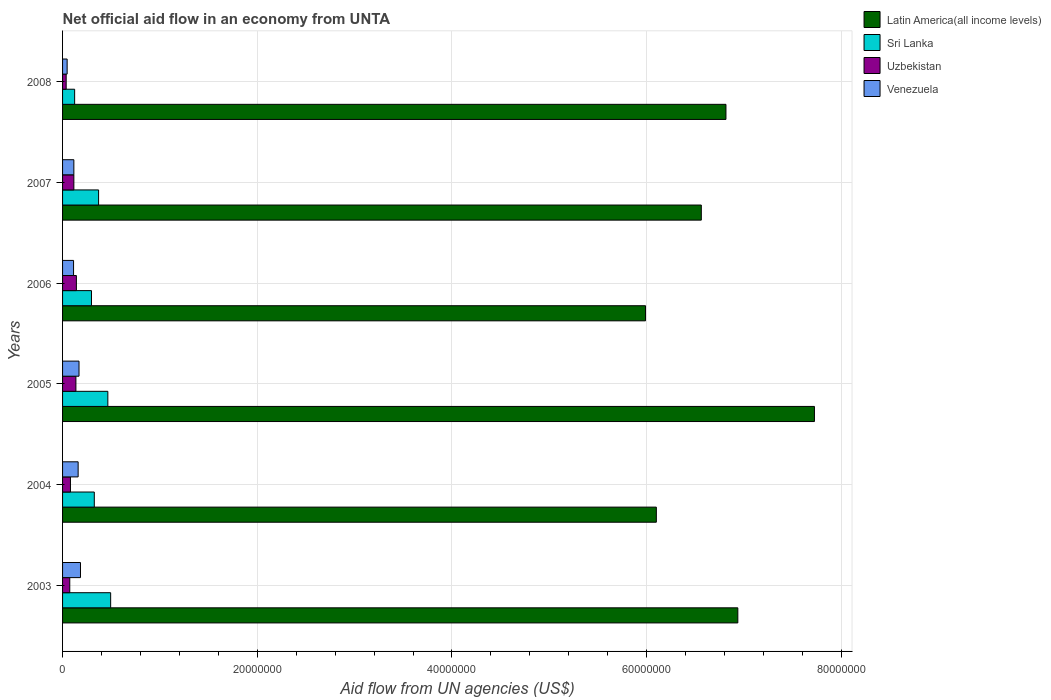Are the number of bars per tick equal to the number of legend labels?
Offer a terse response. Yes. How many bars are there on the 3rd tick from the bottom?
Ensure brevity in your answer.  4. What is the label of the 1st group of bars from the top?
Provide a succinct answer. 2008. In how many cases, is the number of bars for a given year not equal to the number of legend labels?
Give a very brief answer. 0. What is the net official aid flow in Venezuela in 2005?
Offer a very short reply. 1.69e+06. Across all years, what is the maximum net official aid flow in Venezuela?
Provide a short and direct response. 1.84e+06. What is the total net official aid flow in Latin America(all income levels) in the graph?
Your answer should be compact. 4.01e+08. What is the difference between the net official aid flow in Latin America(all income levels) in 2005 and that in 2007?
Offer a terse response. 1.16e+07. What is the average net official aid flow in Latin America(all income levels) per year?
Offer a terse response. 6.69e+07. In the year 2005, what is the difference between the net official aid flow in Latin America(all income levels) and net official aid flow in Sri Lanka?
Make the answer very short. 7.26e+07. In how many years, is the net official aid flow in Uzbekistan greater than 20000000 US$?
Your answer should be very brief. 0. What is the ratio of the net official aid flow in Sri Lanka in 2003 to that in 2008?
Ensure brevity in your answer.  3.98. What is the difference between the highest and the second highest net official aid flow in Sri Lanka?
Ensure brevity in your answer.  2.90e+05. What is the difference between the highest and the lowest net official aid flow in Venezuela?
Ensure brevity in your answer.  1.37e+06. In how many years, is the net official aid flow in Latin America(all income levels) greater than the average net official aid flow in Latin America(all income levels) taken over all years?
Ensure brevity in your answer.  3. Is the sum of the net official aid flow in Sri Lanka in 2003 and 2005 greater than the maximum net official aid flow in Latin America(all income levels) across all years?
Make the answer very short. No. What does the 3rd bar from the top in 2008 represents?
Keep it short and to the point. Sri Lanka. What does the 2nd bar from the bottom in 2008 represents?
Your response must be concise. Sri Lanka. What is the difference between two consecutive major ticks on the X-axis?
Keep it short and to the point. 2.00e+07. Are the values on the major ticks of X-axis written in scientific E-notation?
Make the answer very short. No. Does the graph contain any zero values?
Offer a terse response. No. Does the graph contain grids?
Make the answer very short. Yes. How many legend labels are there?
Provide a short and direct response. 4. How are the legend labels stacked?
Your answer should be compact. Vertical. What is the title of the graph?
Provide a short and direct response. Net official aid flow in an economy from UNTA. Does "Eritrea" appear as one of the legend labels in the graph?
Ensure brevity in your answer.  No. What is the label or title of the X-axis?
Offer a very short reply. Aid flow from UN agencies (US$). What is the label or title of the Y-axis?
Keep it short and to the point. Years. What is the Aid flow from UN agencies (US$) in Latin America(all income levels) in 2003?
Provide a short and direct response. 6.94e+07. What is the Aid flow from UN agencies (US$) in Sri Lanka in 2003?
Offer a terse response. 4.94e+06. What is the Aid flow from UN agencies (US$) in Uzbekistan in 2003?
Your answer should be very brief. 7.40e+05. What is the Aid flow from UN agencies (US$) of Venezuela in 2003?
Provide a succinct answer. 1.84e+06. What is the Aid flow from UN agencies (US$) in Latin America(all income levels) in 2004?
Offer a terse response. 6.10e+07. What is the Aid flow from UN agencies (US$) of Sri Lanka in 2004?
Provide a succinct answer. 3.26e+06. What is the Aid flow from UN agencies (US$) of Uzbekistan in 2004?
Give a very brief answer. 8.10e+05. What is the Aid flow from UN agencies (US$) in Venezuela in 2004?
Your response must be concise. 1.60e+06. What is the Aid flow from UN agencies (US$) in Latin America(all income levels) in 2005?
Your answer should be compact. 7.72e+07. What is the Aid flow from UN agencies (US$) in Sri Lanka in 2005?
Offer a terse response. 4.65e+06. What is the Aid flow from UN agencies (US$) of Uzbekistan in 2005?
Provide a short and direct response. 1.37e+06. What is the Aid flow from UN agencies (US$) in Venezuela in 2005?
Provide a short and direct response. 1.69e+06. What is the Aid flow from UN agencies (US$) in Latin America(all income levels) in 2006?
Offer a very short reply. 5.99e+07. What is the Aid flow from UN agencies (US$) of Sri Lanka in 2006?
Your answer should be very brief. 2.97e+06. What is the Aid flow from UN agencies (US$) in Uzbekistan in 2006?
Offer a terse response. 1.42e+06. What is the Aid flow from UN agencies (US$) in Venezuela in 2006?
Provide a short and direct response. 1.13e+06. What is the Aid flow from UN agencies (US$) in Latin America(all income levels) in 2007?
Give a very brief answer. 6.56e+07. What is the Aid flow from UN agencies (US$) in Sri Lanka in 2007?
Make the answer very short. 3.70e+06. What is the Aid flow from UN agencies (US$) of Uzbekistan in 2007?
Offer a very short reply. 1.16e+06. What is the Aid flow from UN agencies (US$) of Venezuela in 2007?
Keep it short and to the point. 1.16e+06. What is the Aid flow from UN agencies (US$) of Latin America(all income levels) in 2008?
Your answer should be compact. 6.81e+07. What is the Aid flow from UN agencies (US$) of Sri Lanka in 2008?
Give a very brief answer. 1.24e+06. Across all years, what is the maximum Aid flow from UN agencies (US$) of Latin America(all income levels)?
Your response must be concise. 7.72e+07. Across all years, what is the maximum Aid flow from UN agencies (US$) of Sri Lanka?
Keep it short and to the point. 4.94e+06. Across all years, what is the maximum Aid flow from UN agencies (US$) of Uzbekistan?
Provide a short and direct response. 1.42e+06. Across all years, what is the maximum Aid flow from UN agencies (US$) of Venezuela?
Ensure brevity in your answer.  1.84e+06. Across all years, what is the minimum Aid flow from UN agencies (US$) in Latin America(all income levels)?
Offer a terse response. 5.99e+07. Across all years, what is the minimum Aid flow from UN agencies (US$) of Sri Lanka?
Give a very brief answer. 1.24e+06. Across all years, what is the minimum Aid flow from UN agencies (US$) in Uzbekistan?
Your response must be concise. 3.70e+05. What is the total Aid flow from UN agencies (US$) of Latin America(all income levels) in the graph?
Offer a very short reply. 4.01e+08. What is the total Aid flow from UN agencies (US$) in Sri Lanka in the graph?
Offer a terse response. 2.08e+07. What is the total Aid flow from UN agencies (US$) in Uzbekistan in the graph?
Your response must be concise. 5.87e+06. What is the total Aid flow from UN agencies (US$) in Venezuela in the graph?
Your response must be concise. 7.89e+06. What is the difference between the Aid flow from UN agencies (US$) in Latin America(all income levels) in 2003 and that in 2004?
Offer a terse response. 8.37e+06. What is the difference between the Aid flow from UN agencies (US$) of Sri Lanka in 2003 and that in 2004?
Your response must be concise. 1.68e+06. What is the difference between the Aid flow from UN agencies (US$) in Uzbekistan in 2003 and that in 2004?
Keep it short and to the point. -7.00e+04. What is the difference between the Aid flow from UN agencies (US$) of Latin America(all income levels) in 2003 and that in 2005?
Give a very brief answer. -7.87e+06. What is the difference between the Aid flow from UN agencies (US$) of Uzbekistan in 2003 and that in 2005?
Provide a succinct answer. -6.30e+05. What is the difference between the Aid flow from UN agencies (US$) of Venezuela in 2003 and that in 2005?
Your response must be concise. 1.50e+05. What is the difference between the Aid flow from UN agencies (US$) in Latin America(all income levels) in 2003 and that in 2006?
Provide a short and direct response. 9.48e+06. What is the difference between the Aid flow from UN agencies (US$) of Sri Lanka in 2003 and that in 2006?
Offer a terse response. 1.97e+06. What is the difference between the Aid flow from UN agencies (US$) in Uzbekistan in 2003 and that in 2006?
Provide a short and direct response. -6.80e+05. What is the difference between the Aid flow from UN agencies (US$) in Venezuela in 2003 and that in 2006?
Offer a very short reply. 7.10e+05. What is the difference between the Aid flow from UN agencies (US$) in Latin America(all income levels) in 2003 and that in 2007?
Your answer should be very brief. 3.75e+06. What is the difference between the Aid flow from UN agencies (US$) of Sri Lanka in 2003 and that in 2007?
Your answer should be very brief. 1.24e+06. What is the difference between the Aid flow from UN agencies (US$) of Uzbekistan in 2003 and that in 2007?
Your answer should be very brief. -4.20e+05. What is the difference between the Aid flow from UN agencies (US$) in Venezuela in 2003 and that in 2007?
Provide a short and direct response. 6.80e+05. What is the difference between the Aid flow from UN agencies (US$) of Latin America(all income levels) in 2003 and that in 2008?
Keep it short and to the point. 1.22e+06. What is the difference between the Aid flow from UN agencies (US$) in Sri Lanka in 2003 and that in 2008?
Offer a terse response. 3.70e+06. What is the difference between the Aid flow from UN agencies (US$) of Uzbekistan in 2003 and that in 2008?
Give a very brief answer. 3.70e+05. What is the difference between the Aid flow from UN agencies (US$) in Venezuela in 2003 and that in 2008?
Offer a very short reply. 1.37e+06. What is the difference between the Aid flow from UN agencies (US$) of Latin America(all income levels) in 2004 and that in 2005?
Ensure brevity in your answer.  -1.62e+07. What is the difference between the Aid flow from UN agencies (US$) of Sri Lanka in 2004 and that in 2005?
Your answer should be very brief. -1.39e+06. What is the difference between the Aid flow from UN agencies (US$) in Uzbekistan in 2004 and that in 2005?
Give a very brief answer. -5.60e+05. What is the difference between the Aid flow from UN agencies (US$) in Latin America(all income levels) in 2004 and that in 2006?
Provide a succinct answer. 1.11e+06. What is the difference between the Aid flow from UN agencies (US$) of Uzbekistan in 2004 and that in 2006?
Offer a very short reply. -6.10e+05. What is the difference between the Aid flow from UN agencies (US$) of Venezuela in 2004 and that in 2006?
Give a very brief answer. 4.70e+05. What is the difference between the Aid flow from UN agencies (US$) in Latin America(all income levels) in 2004 and that in 2007?
Make the answer very short. -4.62e+06. What is the difference between the Aid flow from UN agencies (US$) of Sri Lanka in 2004 and that in 2007?
Your response must be concise. -4.40e+05. What is the difference between the Aid flow from UN agencies (US$) of Uzbekistan in 2004 and that in 2007?
Give a very brief answer. -3.50e+05. What is the difference between the Aid flow from UN agencies (US$) in Latin America(all income levels) in 2004 and that in 2008?
Ensure brevity in your answer.  -7.15e+06. What is the difference between the Aid flow from UN agencies (US$) in Sri Lanka in 2004 and that in 2008?
Your response must be concise. 2.02e+06. What is the difference between the Aid flow from UN agencies (US$) in Venezuela in 2004 and that in 2008?
Your answer should be very brief. 1.13e+06. What is the difference between the Aid flow from UN agencies (US$) of Latin America(all income levels) in 2005 and that in 2006?
Your response must be concise. 1.74e+07. What is the difference between the Aid flow from UN agencies (US$) in Sri Lanka in 2005 and that in 2006?
Provide a short and direct response. 1.68e+06. What is the difference between the Aid flow from UN agencies (US$) in Uzbekistan in 2005 and that in 2006?
Keep it short and to the point. -5.00e+04. What is the difference between the Aid flow from UN agencies (US$) in Venezuela in 2005 and that in 2006?
Provide a short and direct response. 5.60e+05. What is the difference between the Aid flow from UN agencies (US$) of Latin America(all income levels) in 2005 and that in 2007?
Provide a succinct answer. 1.16e+07. What is the difference between the Aid flow from UN agencies (US$) of Sri Lanka in 2005 and that in 2007?
Make the answer very short. 9.50e+05. What is the difference between the Aid flow from UN agencies (US$) of Venezuela in 2005 and that in 2007?
Offer a terse response. 5.30e+05. What is the difference between the Aid flow from UN agencies (US$) in Latin America(all income levels) in 2005 and that in 2008?
Keep it short and to the point. 9.09e+06. What is the difference between the Aid flow from UN agencies (US$) of Sri Lanka in 2005 and that in 2008?
Your answer should be compact. 3.41e+06. What is the difference between the Aid flow from UN agencies (US$) in Uzbekistan in 2005 and that in 2008?
Give a very brief answer. 1.00e+06. What is the difference between the Aid flow from UN agencies (US$) in Venezuela in 2005 and that in 2008?
Keep it short and to the point. 1.22e+06. What is the difference between the Aid flow from UN agencies (US$) in Latin America(all income levels) in 2006 and that in 2007?
Keep it short and to the point. -5.73e+06. What is the difference between the Aid flow from UN agencies (US$) of Sri Lanka in 2006 and that in 2007?
Offer a terse response. -7.30e+05. What is the difference between the Aid flow from UN agencies (US$) of Latin America(all income levels) in 2006 and that in 2008?
Offer a terse response. -8.26e+06. What is the difference between the Aid flow from UN agencies (US$) in Sri Lanka in 2006 and that in 2008?
Ensure brevity in your answer.  1.73e+06. What is the difference between the Aid flow from UN agencies (US$) in Uzbekistan in 2006 and that in 2008?
Offer a very short reply. 1.05e+06. What is the difference between the Aid flow from UN agencies (US$) of Latin America(all income levels) in 2007 and that in 2008?
Your answer should be very brief. -2.53e+06. What is the difference between the Aid flow from UN agencies (US$) of Sri Lanka in 2007 and that in 2008?
Make the answer very short. 2.46e+06. What is the difference between the Aid flow from UN agencies (US$) in Uzbekistan in 2007 and that in 2008?
Your answer should be compact. 7.90e+05. What is the difference between the Aid flow from UN agencies (US$) of Venezuela in 2007 and that in 2008?
Keep it short and to the point. 6.90e+05. What is the difference between the Aid flow from UN agencies (US$) of Latin America(all income levels) in 2003 and the Aid flow from UN agencies (US$) of Sri Lanka in 2004?
Your response must be concise. 6.61e+07. What is the difference between the Aid flow from UN agencies (US$) in Latin America(all income levels) in 2003 and the Aid flow from UN agencies (US$) in Uzbekistan in 2004?
Give a very brief answer. 6.86e+07. What is the difference between the Aid flow from UN agencies (US$) of Latin America(all income levels) in 2003 and the Aid flow from UN agencies (US$) of Venezuela in 2004?
Provide a succinct answer. 6.78e+07. What is the difference between the Aid flow from UN agencies (US$) of Sri Lanka in 2003 and the Aid flow from UN agencies (US$) of Uzbekistan in 2004?
Provide a succinct answer. 4.13e+06. What is the difference between the Aid flow from UN agencies (US$) of Sri Lanka in 2003 and the Aid flow from UN agencies (US$) of Venezuela in 2004?
Keep it short and to the point. 3.34e+06. What is the difference between the Aid flow from UN agencies (US$) in Uzbekistan in 2003 and the Aid flow from UN agencies (US$) in Venezuela in 2004?
Your answer should be compact. -8.60e+05. What is the difference between the Aid flow from UN agencies (US$) of Latin America(all income levels) in 2003 and the Aid flow from UN agencies (US$) of Sri Lanka in 2005?
Your answer should be very brief. 6.47e+07. What is the difference between the Aid flow from UN agencies (US$) in Latin America(all income levels) in 2003 and the Aid flow from UN agencies (US$) in Uzbekistan in 2005?
Provide a short and direct response. 6.80e+07. What is the difference between the Aid flow from UN agencies (US$) of Latin America(all income levels) in 2003 and the Aid flow from UN agencies (US$) of Venezuela in 2005?
Offer a very short reply. 6.77e+07. What is the difference between the Aid flow from UN agencies (US$) of Sri Lanka in 2003 and the Aid flow from UN agencies (US$) of Uzbekistan in 2005?
Provide a succinct answer. 3.57e+06. What is the difference between the Aid flow from UN agencies (US$) in Sri Lanka in 2003 and the Aid flow from UN agencies (US$) in Venezuela in 2005?
Provide a succinct answer. 3.25e+06. What is the difference between the Aid flow from UN agencies (US$) in Uzbekistan in 2003 and the Aid flow from UN agencies (US$) in Venezuela in 2005?
Your response must be concise. -9.50e+05. What is the difference between the Aid flow from UN agencies (US$) of Latin America(all income levels) in 2003 and the Aid flow from UN agencies (US$) of Sri Lanka in 2006?
Provide a succinct answer. 6.64e+07. What is the difference between the Aid flow from UN agencies (US$) in Latin America(all income levels) in 2003 and the Aid flow from UN agencies (US$) in Uzbekistan in 2006?
Offer a very short reply. 6.79e+07. What is the difference between the Aid flow from UN agencies (US$) in Latin America(all income levels) in 2003 and the Aid flow from UN agencies (US$) in Venezuela in 2006?
Your response must be concise. 6.82e+07. What is the difference between the Aid flow from UN agencies (US$) of Sri Lanka in 2003 and the Aid flow from UN agencies (US$) of Uzbekistan in 2006?
Offer a terse response. 3.52e+06. What is the difference between the Aid flow from UN agencies (US$) in Sri Lanka in 2003 and the Aid flow from UN agencies (US$) in Venezuela in 2006?
Keep it short and to the point. 3.81e+06. What is the difference between the Aid flow from UN agencies (US$) in Uzbekistan in 2003 and the Aid flow from UN agencies (US$) in Venezuela in 2006?
Your answer should be compact. -3.90e+05. What is the difference between the Aid flow from UN agencies (US$) of Latin America(all income levels) in 2003 and the Aid flow from UN agencies (US$) of Sri Lanka in 2007?
Keep it short and to the point. 6.57e+07. What is the difference between the Aid flow from UN agencies (US$) in Latin America(all income levels) in 2003 and the Aid flow from UN agencies (US$) in Uzbekistan in 2007?
Provide a succinct answer. 6.82e+07. What is the difference between the Aid flow from UN agencies (US$) in Latin America(all income levels) in 2003 and the Aid flow from UN agencies (US$) in Venezuela in 2007?
Give a very brief answer. 6.82e+07. What is the difference between the Aid flow from UN agencies (US$) of Sri Lanka in 2003 and the Aid flow from UN agencies (US$) of Uzbekistan in 2007?
Provide a short and direct response. 3.78e+06. What is the difference between the Aid flow from UN agencies (US$) of Sri Lanka in 2003 and the Aid flow from UN agencies (US$) of Venezuela in 2007?
Make the answer very short. 3.78e+06. What is the difference between the Aid flow from UN agencies (US$) in Uzbekistan in 2003 and the Aid flow from UN agencies (US$) in Venezuela in 2007?
Provide a succinct answer. -4.20e+05. What is the difference between the Aid flow from UN agencies (US$) in Latin America(all income levels) in 2003 and the Aid flow from UN agencies (US$) in Sri Lanka in 2008?
Keep it short and to the point. 6.81e+07. What is the difference between the Aid flow from UN agencies (US$) of Latin America(all income levels) in 2003 and the Aid flow from UN agencies (US$) of Uzbekistan in 2008?
Your response must be concise. 6.90e+07. What is the difference between the Aid flow from UN agencies (US$) in Latin America(all income levels) in 2003 and the Aid flow from UN agencies (US$) in Venezuela in 2008?
Offer a very short reply. 6.89e+07. What is the difference between the Aid flow from UN agencies (US$) of Sri Lanka in 2003 and the Aid flow from UN agencies (US$) of Uzbekistan in 2008?
Provide a succinct answer. 4.57e+06. What is the difference between the Aid flow from UN agencies (US$) of Sri Lanka in 2003 and the Aid flow from UN agencies (US$) of Venezuela in 2008?
Offer a terse response. 4.47e+06. What is the difference between the Aid flow from UN agencies (US$) in Uzbekistan in 2003 and the Aid flow from UN agencies (US$) in Venezuela in 2008?
Offer a terse response. 2.70e+05. What is the difference between the Aid flow from UN agencies (US$) of Latin America(all income levels) in 2004 and the Aid flow from UN agencies (US$) of Sri Lanka in 2005?
Offer a very short reply. 5.63e+07. What is the difference between the Aid flow from UN agencies (US$) in Latin America(all income levels) in 2004 and the Aid flow from UN agencies (US$) in Uzbekistan in 2005?
Offer a very short reply. 5.96e+07. What is the difference between the Aid flow from UN agencies (US$) of Latin America(all income levels) in 2004 and the Aid flow from UN agencies (US$) of Venezuela in 2005?
Provide a succinct answer. 5.93e+07. What is the difference between the Aid flow from UN agencies (US$) of Sri Lanka in 2004 and the Aid flow from UN agencies (US$) of Uzbekistan in 2005?
Your answer should be compact. 1.89e+06. What is the difference between the Aid flow from UN agencies (US$) of Sri Lanka in 2004 and the Aid flow from UN agencies (US$) of Venezuela in 2005?
Offer a very short reply. 1.57e+06. What is the difference between the Aid flow from UN agencies (US$) in Uzbekistan in 2004 and the Aid flow from UN agencies (US$) in Venezuela in 2005?
Keep it short and to the point. -8.80e+05. What is the difference between the Aid flow from UN agencies (US$) of Latin America(all income levels) in 2004 and the Aid flow from UN agencies (US$) of Sri Lanka in 2006?
Provide a short and direct response. 5.80e+07. What is the difference between the Aid flow from UN agencies (US$) in Latin America(all income levels) in 2004 and the Aid flow from UN agencies (US$) in Uzbekistan in 2006?
Your response must be concise. 5.96e+07. What is the difference between the Aid flow from UN agencies (US$) of Latin America(all income levels) in 2004 and the Aid flow from UN agencies (US$) of Venezuela in 2006?
Ensure brevity in your answer.  5.99e+07. What is the difference between the Aid flow from UN agencies (US$) of Sri Lanka in 2004 and the Aid flow from UN agencies (US$) of Uzbekistan in 2006?
Your response must be concise. 1.84e+06. What is the difference between the Aid flow from UN agencies (US$) in Sri Lanka in 2004 and the Aid flow from UN agencies (US$) in Venezuela in 2006?
Your answer should be compact. 2.13e+06. What is the difference between the Aid flow from UN agencies (US$) in Uzbekistan in 2004 and the Aid flow from UN agencies (US$) in Venezuela in 2006?
Ensure brevity in your answer.  -3.20e+05. What is the difference between the Aid flow from UN agencies (US$) in Latin America(all income levels) in 2004 and the Aid flow from UN agencies (US$) in Sri Lanka in 2007?
Your answer should be compact. 5.73e+07. What is the difference between the Aid flow from UN agencies (US$) of Latin America(all income levels) in 2004 and the Aid flow from UN agencies (US$) of Uzbekistan in 2007?
Offer a terse response. 5.98e+07. What is the difference between the Aid flow from UN agencies (US$) of Latin America(all income levels) in 2004 and the Aid flow from UN agencies (US$) of Venezuela in 2007?
Your response must be concise. 5.98e+07. What is the difference between the Aid flow from UN agencies (US$) in Sri Lanka in 2004 and the Aid flow from UN agencies (US$) in Uzbekistan in 2007?
Keep it short and to the point. 2.10e+06. What is the difference between the Aid flow from UN agencies (US$) of Sri Lanka in 2004 and the Aid flow from UN agencies (US$) of Venezuela in 2007?
Offer a terse response. 2.10e+06. What is the difference between the Aid flow from UN agencies (US$) of Uzbekistan in 2004 and the Aid flow from UN agencies (US$) of Venezuela in 2007?
Give a very brief answer. -3.50e+05. What is the difference between the Aid flow from UN agencies (US$) of Latin America(all income levels) in 2004 and the Aid flow from UN agencies (US$) of Sri Lanka in 2008?
Your response must be concise. 5.98e+07. What is the difference between the Aid flow from UN agencies (US$) of Latin America(all income levels) in 2004 and the Aid flow from UN agencies (US$) of Uzbekistan in 2008?
Offer a very short reply. 6.06e+07. What is the difference between the Aid flow from UN agencies (US$) in Latin America(all income levels) in 2004 and the Aid flow from UN agencies (US$) in Venezuela in 2008?
Give a very brief answer. 6.05e+07. What is the difference between the Aid flow from UN agencies (US$) of Sri Lanka in 2004 and the Aid flow from UN agencies (US$) of Uzbekistan in 2008?
Provide a succinct answer. 2.89e+06. What is the difference between the Aid flow from UN agencies (US$) in Sri Lanka in 2004 and the Aid flow from UN agencies (US$) in Venezuela in 2008?
Provide a short and direct response. 2.79e+06. What is the difference between the Aid flow from UN agencies (US$) of Uzbekistan in 2004 and the Aid flow from UN agencies (US$) of Venezuela in 2008?
Ensure brevity in your answer.  3.40e+05. What is the difference between the Aid flow from UN agencies (US$) of Latin America(all income levels) in 2005 and the Aid flow from UN agencies (US$) of Sri Lanka in 2006?
Offer a terse response. 7.43e+07. What is the difference between the Aid flow from UN agencies (US$) in Latin America(all income levels) in 2005 and the Aid flow from UN agencies (US$) in Uzbekistan in 2006?
Give a very brief answer. 7.58e+07. What is the difference between the Aid flow from UN agencies (US$) of Latin America(all income levels) in 2005 and the Aid flow from UN agencies (US$) of Venezuela in 2006?
Your response must be concise. 7.61e+07. What is the difference between the Aid flow from UN agencies (US$) in Sri Lanka in 2005 and the Aid flow from UN agencies (US$) in Uzbekistan in 2006?
Provide a succinct answer. 3.23e+06. What is the difference between the Aid flow from UN agencies (US$) of Sri Lanka in 2005 and the Aid flow from UN agencies (US$) of Venezuela in 2006?
Ensure brevity in your answer.  3.52e+06. What is the difference between the Aid flow from UN agencies (US$) in Latin America(all income levels) in 2005 and the Aid flow from UN agencies (US$) in Sri Lanka in 2007?
Offer a terse response. 7.35e+07. What is the difference between the Aid flow from UN agencies (US$) of Latin America(all income levels) in 2005 and the Aid flow from UN agencies (US$) of Uzbekistan in 2007?
Provide a short and direct response. 7.61e+07. What is the difference between the Aid flow from UN agencies (US$) in Latin America(all income levels) in 2005 and the Aid flow from UN agencies (US$) in Venezuela in 2007?
Your response must be concise. 7.61e+07. What is the difference between the Aid flow from UN agencies (US$) of Sri Lanka in 2005 and the Aid flow from UN agencies (US$) of Uzbekistan in 2007?
Your answer should be very brief. 3.49e+06. What is the difference between the Aid flow from UN agencies (US$) in Sri Lanka in 2005 and the Aid flow from UN agencies (US$) in Venezuela in 2007?
Your answer should be compact. 3.49e+06. What is the difference between the Aid flow from UN agencies (US$) in Latin America(all income levels) in 2005 and the Aid flow from UN agencies (US$) in Sri Lanka in 2008?
Provide a succinct answer. 7.60e+07. What is the difference between the Aid flow from UN agencies (US$) in Latin America(all income levels) in 2005 and the Aid flow from UN agencies (US$) in Uzbekistan in 2008?
Offer a terse response. 7.69e+07. What is the difference between the Aid flow from UN agencies (US$) in Latin America(all income levels) in 2005 and the Aid flow from UN agencies (US$) in Venezuela in 2008?
Give a very brief answer. 7.68e+07. What is the difference between the Aid flow from UN agencies (US$) of Sri Lanka in 2005 and the Aid flow from UN agencies (US$) of Uzbekistan in 2008?
Ensure brevity in your answer.  4.28e+06. What is the difference between the Aid flow from UN agencies (US$) of Sri Lanka in 2005 and the Aid flow from UN agencies (US$) of Venezuela in 2008?
Offer a very short reply. 4.18e+06. What is the difference between the Aid flow from UN agencies (US$) in Uzbekistan in 2005 and the Aid flow from UN agencies (US$) in Venezuela in 2008?
Your answer should be compact. 9.00e+05. What is the difference between the Aid flow from UN agencies (US$) of Latin America(all income levels) in 2006 and the Aid flow from UN agencies (US$) of Sri Lanka in 2007?
Give a very brief answer. 5.62e+07. What is the difference between the Aid flow from UN agencies (US$) in Latin America(all income levels) in 2006 and the Aid flow from UN agencies (US$) in Uzbekistan in 2007?
Your answer should be very brief. 5.87e+07. What is the difference between the Aid flow from UN agencies (US$) in Latin America(all income levels) in 2006 and the Aid flow from UN agencies (US$) in Venezuela in 2007?
Offer a terse response. 5.87e+07. What is the difference between the Aid flow from UN agencies (US$) of Sri Lanka in 2006 and the Aid flow from UN agencies (US$) of Uzbekistan in 2007?
Give a very brief answer. 1.81e+06. What is the difference between the Aid flow from UN agencies (US$) in Sri Lanka in 2006 and the Aid flow from UN agencies (US$) in Venezuela in 2007?
Give a very brief answer. 1.81e+06. What is the difference between the Aid flow from UN agencies (US$) in Latin America(all income levels) in 2006 and the Aid flow from UN agencies (US$) in Sri Lanka in 2008?
Provide a succinct answer. 5.86e+07. What is the difference between the Aid flow from UN agencies (US$) in Latin America(all income levels) in 2006 and the Aid flow from UN agencies (US$) in Uzbekistan in 2008?
Provide a short and direct response. 5.95e+07. What is the difference between the Aid flow from UN agencies (US$) in Latin America(all income levels) in 2006 and the Aid flow from UN agencies (US$) in Venezuela in 2008?
Offer a terse response. 5.94e+07. What is the difference between the Aid flow from UN agencies (US$) in Sri Lanka in 2006 and the Aid flow from UN agencies (US$) in Uzbekistan in 2008?
Keep it short and to the point. 2.60e+06. What is the difference between the Aid flow from UN agencies (US$) of Sri Lanka in 2006 and the Aid flow from UN agencies (US$) of Venezuela in 2008?
Provide a short and direct response. 2.50e+06. What is the difference between the Aid flow from UN agencies (US$) in Uzbekistan in 2006 and the Aid flow from UN agencies (US$) in Venezuela in 2008?
Your answer should be very brief. 9.50e+05. What is the difference between the Aid flow from UN agencies (US$) of Latin America(all income levels) in 2007 and the Aid flow from UN agencies (US$) of Sri Lanka in 2008?
Your response must be concise. 6.44e+07. What is the difference between the Aid flow from UN agencies (US$) in Latin America(all income levels) in 2007 and the Aid flow from UN agencies (US$) in Uzbekistan in 2008?
Make the answer very short. 6.52e+07. What is the difference between the Aid flow from UN agencies (US$) of Latin America(all income levels) in 2007 and the Aid flow from UN agencies (US$) of Venezuela in 2008?
Keep it short and to the point. 6.51e+07. What is the difference between the Aid flow from UN agencies (US$) of Sri Lanka in 2007 and the Aid flow from UN agencies (US$) of Uzbekistan in 2008?
Make the answer very short. 3.33e+06. What is the difference between the Aid flow from UN agencies (US$) of Sri Lanka in 2007 and the Aid flow from UN agencies (US$) of Venezuela in 2008?
Your response must be concise. 3.23e+06. What is the difference between the Aid flow from UN agencies (US$) in Uzbekistan in 2007 and the Aid flow from UN agencies (US$) in Venezuela in 2008?
Provide a succinct answer. 6.90e+05. What is the average Aid flow from UN agencies (US$) in Latin America(all income levels) per year?
Offer a very short reply. 6.69e+07. What is the average Aid flow from UN agencies (US$) of Sri Lanka per year?
Your response must be concise. 3.46e+06. What is the average Aid flow from UN agencies (US$) of Uzbekistan per year?
Offer a very short reply. 9.78e+05. What is the average Aid flow from UN agencies (US$) in Venezuela per year?
Give a very brief answer. 1.32e+06. In the year 2003, what is the difference between the Aid flow from UN agencies (US$) in Latin America(all income levels) and Aid flow from UN agencies (US$) in Sri Lanka?
Offer a terse response. 6.44e+07. In the year 2003, what is the difference between the Aid flow from UN agencies (US$) of Latin America(all income levels) and Aid flow from UN agencies (US$) of Uzbekistan?
Keep it short and to the point. 6.86e+07. In the year 2003, what is the difference between the Aid flow from UN agencies (US$) of Latin America(all income levels) and Aid flow from UN agencies (US$) of Venezuela?
Keep it short and to the point. 6.75e+07. In the year 2003, what is the difference between the Aid flow from UN agencies (US$) in Sri Lanka and Aid flow from UN agencies (US$) in Uzbekistan?
Give a very brief answer. 4.20e+06. In the year 2003, what is the difference between the Aid flow from UN agencies (US$) of Sri Lanka and Aid flow from UN agencies (US$) of Venezuela?
Offer a very short reply. 3.10e+06. In the year 2003, what is the difference between the Aid flow from UN agencies (US$) in Uzbekistan and Aid flow from UN agencies (US$) in Venezuela?
Make the answer very short. -1.10e+06. In the year 2004, what is the difference between the Aid flow from UN agencies (US$) in Latin America(all income levels) and Aid flow from UN agencies (US$) in Sri Lanka?
Provide a short and direct response. 5.77e+07. In the year 2004, what is the difference between the Aid flow from UN agencies (US$) of Latin America(all income levels) and Aid flow from UN agencies (US$) of Uzbekistan?
Your answer should be compact. 6.02e+07. In the year 2004, what is the difference between the Aid flow from UN agencies (US$) in Latin America(all income levels) and Aid flow from UN agencies (US$) in Venezuela?
Give a very brief answer. 5.94e+07. In the year 2004, what is the difference between the Aid flow from UN agencies (US$) in Sri Lanka and Aid flow from UN agencies (US$) in Uzbekistan?
Offer a terse response. 2.45e+06. In the year 2004, what is the difference between the Aid flow from UN agencies (US$) in Sri Lanka and Aid flow from UN agencies (US$) in Venezuela?
Your answer should be compact. 1.66e+06. In the year 2004, what is the difference between the Aid flow from UN agencies (US$) in Uzbekistan and Aid flow from UN agencies (US$) in Venezuela?
Offer a terse response. -7.90e+05. In the year 2005, what is the difference between the Aid flow from UN agencies (US$) of Latin America(all income levels) and Aid flow from UN agencies (US$) of Sri Lanka?
Give a very brief answer. 7.26e+07. In the year 2005, what is the difference between the Aid flow from UN agencies (US$) of Latin America(all income levels) and Aid flow from UN agencies (US$) of Uzbekistan?
Provide a succinct answer. 7.59e+07. In the year 2005, what is the difference between the Aid flow from UN agencies (US$) in Latin America(all income levels) and Aid flow from UN agencies (US$) in Venezuela?
Give a very brief answer. 7.55e+07. In the year 2005, what is the difference between the Aid flow from UN agencies (US$) of Sri Lanka and Aid flow from UN agencies (US$) of Uzbekistan?
Give a very brief answer. 3.28e+06. In the year 2005, what is the difference between the Aid flow from UN agencies (US$) in Sri Lanka and Aid flow from UN agencies (US$) in Venezuela?
Ensure brevity in your answer.  2.96e+06. In the year 2005, what is the difference between the Aid flow from UN agencies (US$) of Uzbekistan and Aid flow from UN agencies (US$) of Venezuela?
Offer a terse response. -3.20e+05. In the year 2006, what is the difference between the Aid flow from UN agencies (US$) in Latin America(all income levels) and Aid flow from UN agencies (US$) in Sri Lanka?
Your answer should be very brief. 5.69e+07. In the year 2006, what is the difference between the Aid flow from UN agencies (US$) of Latin America(all income levels) and Aid flow from UN agencies (US$) of Uzbekistan?
Ensure brevity in your answer.  5.85e+07. In the year 2006, what is the difference between the Aid flow from UN agencies (US$) of Latin America(all income levels) and Aid flow from UN agencies (US$) of Venezuela?
Ensure brevity in your answer.  5.88e+07. In the year 2006, what is the difference between the Aid flow from UN agencies (US$) in Sri Lanka and Aid flow from UN agencies (US$) in Uzbekistan?
Your answer should be very brief. 1.55e+06. In the year 2006, what is the difference between the Aid flow from UN agencies (US$) of Sri Lanka and Aid flow from UN agencies (US$) of Venezuela?
Your answer should be very brief. 1.84e+06. In the year 2007, what is the difference between the Aid flow from UN agencies (US$) in Latin America(all income levels) and Aid flow from UN agencies (US$) in Sri Lanka?
Your answer should be very brief. 6.19e+07. In the year 2007, what is the difference between the Aid flow from UN agencies (US$) of Latin America(all income levels) and Aid flow from UN agencies (US$) of Uzbekistan?
Provide a short and direct response. 6.44e+07. In the year 2007, what is the difference between the Aid flow from UN agencies (US$) of Latin America(all income levels) and Aid flow from UN agencies (US$) of Venezuela?
Your answer should be compact. 6.44e+07. In the year 2007, what is the difference between the Aid flow from UN agencies (US$) in Sri Lanka and Aid flow from UN agencies (US$) in Uzbekistan?
Your response must be concise. 2.54e+06. In the year 2007, what is the difference between the Aid flow from UN agencies (US$) of Sri Lanka and Aid flow from UN agencies (US$) of Venezuela?
Give a very brief answer. 2.54e+06. In the year 2007, what is the difference between the Aid flow from UN agencies (US$) in Uzbekistan and Aid flow from UN agencies (US$) in Venezuela?
Provide a short and direct response. 0. In the year 2008, what is the difference between the Aid flow from UN agencies (US$) of Latin America(all income levels) and Aid flow from UN agencies (US$) of Sri Lanka?
Keep it short and to the point. 6.69e+07. In the year 2008, what is the difference between the Aid flow from UN agencies (US$) in Latin America(all income levels) and Aid flow from UN agencies (US$) in Uzbekistan?
Your answer should be compact. 6.78e+07. In the year 2008, what is the difference between the Aid flow from UN agencies (US$) of Latin America(all income levels) and Aid flow from UN agencies (US$) of Venezuela?
Offer a terse response. 6.77e+07. In the year 2008, what is the difference between the Aid flow from UN agencies (US$) in Sri Lanka and Aid flow from UN agencies (US$) in Uzbekistan?
Keep it short and to the point. 8.70e+05. In the year 2008, what is the difference between the Aid flow from UN agencies (US$) of Sri Lanka and Aid flow from UN agencies (US$) of Venezuela?
Offer a very short reply. 7.70e+05. In the year 2008, what is the difference between the Aid flow from UN agencies (US$) of Uzbekistan and Aid flow from UN agencies (US$) of Venezuela?
Offer a very short reply. -1.00e+05. What is the ratio of the Aid flow from UN agencies (US$) of Latin America(all income levels) in 2003 to that in 2004?
Ensure brevity in your answer.  1.14. What is the ratio of the Aid flow from UN agencies (US$) of Sri Lanka in 2003 to that in 2004?
Your response must be concise. 1.52. What is the ratio of the Aid flow from UN agencies (US$) of Uzbekistan in 2003 to that in 2004?
Make the answer very short. 0.91. What is the ratio of the Aid flow from UN agencies (US$) of Venezuela in 2003 to that in 2004?
Ensure brevity in your answer.  1.15. What is the ratio of the Aid flow from UN agencies (US$) in Latin America(all income levels) in 2003 to that in 2005?
Make the answer very short. 0.9. What is the ratio of the Aid flow from UN agencies (US$) of Sri Lanka in 2003 to that in 2005?
Keep it short and to the point. 1.06. What is the ratio of the Aid flow from UN agencies (US$) of Uzbekistan in 2003 to that in 2005?
Your response must be concise. 0.54. What is the ratio of the Aid flow from UN agencies (US$) in Venezuela in 2003 to that in 2005?
Offer a very short reply. 1.09. What is the ratio of the Aid flow from UN agencies (US$) in Latin America(all income levels) in 2003 to that in 2006?
Give a very brief answer. 1.16. What is the ratio of the Aid flow from UN agencies (US$) in Sri Lanka in 2003 to that in 2006?
Give a very brief answer. 1.66. What is the ratio of the Aid flow from UN agencies (US$) of Uzbekistan in 2003 to that in 2006?
Your response must be concise. 0.52. What is the ratio of the Aid flow from UN agencies (US$) of Venezuela in 2003 to that in 2006?
Your answer should be very brief. 1.63. What is the ratio of the Aid flow from UN agencies (US$) in Latin America(all income levels) in 2003 to that in 2007?
Give a very brief answer. 1.06. What is the ratio of the Aid flow from UN agencies (US$) in Sri Lanka in 2003 to that in 2007?
Your answer should be very brief. 1.34. What is the ratio of the Aid flow from UN agencies (US$) in Uzbekistan in 2003 to that in 2007?
Offer a very short reply. 0.64. What is the ratio of the Aid flow from UN agencies (US$) of Venezuela in 2003 to that in 2007?
Your answer should be very brief. 1.59. What is the ratio of the Aid flow from UN agencies (US$) in Latin America(all income levels) in 2003 to that in 2008?
Ensure brevity in your answer.  1.02. What is the ratio of the Aid flow from UN agencies (US$) in Sri Lanka in 2003 to that in 2008?
Your answer should be very brief. 3.98. What is the ratio of the Aid flow from UN agencies (US$) in Uzbekistan in 2003 to that in 2008?
Your answer should be compact. 2. What is the ratio of the Aid flow from UN agencies (US$) in Venezuela in 2003 to that in 2008?
Offer a terse response. 3.91. What is the ratio of the Aid flow from UN agencies (US$) of Latin America(all income levels) in 2004 to that in 2005?
Offer a terse response. 0.79. What is the ratio of the Aid flow from UN agencies (US$) in Sri Lanka in 2004 to that in 2005?
Give a very brief answer. 0.7. What is the ratio of the Aid flow from UN agencies (US$) of Uzbekistan in 2004 to that in 2005?
Ensure brevity in your answer.  0.59. What is the ratio of the Aid flow from UN agencies (US$) in Venezuela in 2004 to that in 2005?
Provide a succinct answer. 0.95. What is the ratio of the Aid flow from UN agencies (US$) of Latin America(all income levels) in 2004 to that in 2006?
Ensure brevity in your answer.  1.02. What is the ratio of the Aid flow from UN agencies (US$) of Sri Lanka in 2004 to that in 2006?
Your answer should be compact. 1.1. What is the ratio of the Aid flow from UN agencies (US$) of Uzbekistan in 2004 to that in 2006?
Provide a succinct answer. 0.57. What is the ratio of the Aid flow from UN agencies (US$) of Venezuela in 2004 to that in 2006?
Offer a terse response. 1.42. What is the ratio of the Aid flow from UN agencies (US$) of Latin America(all income levels) in 2004 to that in 2007?
Provide a succinct answer. 0.93. What is the ratio of the Aid flow from UN agencies (US$) in Sri Lanka in 2004 to that in 2007?
Offer a terse response. 0.88. What is the ratio of the Aid flow from UN agencies (US$) in Uzbekistan in 2004 to that in 2007?
Your answer should be very brief. 0.7. What is the ratio of the Aid flow from UN agencies (US$) in Venezuela in 2004 to that in 2007?
Provide a short and direct response. 1.38. What is the ratio of the Aid flow from UN agencies (US$) of Latin America(all income levels) in 2004 to that in 2008?
Give a very brief answer. 0.9. What is the ratio of the Aid flow from UN agencies (US$) of Sri Lanka in 2004 to that in 2008?
Make the answer very short. 2.63. What is the ratio of the Aid flow from UN agencies (US$) in Uzbekistan in 2004 to that in 2008?
Provide a succinct answer. 2.19. What is the ratio of the Aid flow from UN agencies (US$) of Venezuela in 2004 to that in 2008?
Provide a succinct answer. 3.4. What is the ratio of the Aid flow from UN agencies (US$) in Latin America(all income levels) in 2005 to that in 2006?
Offer a very short reply. 1.29. What is the ratio of the Aid flow from UN agencies (US$) in Sri Lanka in 2005 to that in 2006?
Make the answer very short. 1.57. What is the ratio of the Aid flow from UN agencies (US$) in Uzbekistan in 2005 to that in 2006?
Your answer should be compact. 0.96. What is the ratio of the Aid flow from UN agencies (US$) in Venezuela in 2005 to that in 2006?
Your response must be concise. 1.5. What is the ratio of the Aid flow from UN agencies (US$) in Latin America(all income levels) in 2005 to that in 2007?
Provide a short and direct response. 1.18. What is the ratio of the Aid flow from UN agencies (US$) of Sri Lanka in 2005 to that in 2007?
Your response must be concise. 1.26. What is the ratio of the Aid flow from UN agencies (US$) of Uzbekistan in 2005 to that in 2007?
Give a very brief answer. 1.18. What is the ratio of the Aid flow from UN agencies (US$) of Venezuela in 2005 to that in 2007?
Keep it short and to the point. 1.46. What is the ratio of the Aid flow from UN agencies (US$) in Latin America(all income levels) in 2005 to that in 2008?
Provide a succinct answer. 1.13. What is the ratio of the Aid flow from UN agencies (US$) of Sri Lanka in 2005 to that in 2008?
Your response must be concise. 3.75. What is the ratio of the Aid flow from UN agencies (US$) of Uzbekistan in 2005 to that in 2008?
Your answer should be very brief. 3.7. What is the ratio of the Aid flow from UN agencies (US$) in Venezuela in 2005 to that in 2008?
Provide a short and direct response. 3.6. What is the ratio of the Aid flow from UN agencies (US$) of Latin America(all income levels) in 2006 to that in 2007?
Your response must be concise. 0.91. What is the ratio of the Aid flow from UN agencies (US$) in Sri Lanka in 2006 to that in 2007?
Your answer should be compact. 0.8. What is the ratio of the Aid flow from UN agencies (US$) in Uzbekistan in 2006 to that in 2007?
Make the answer very short. 1.22. What is the ratio of the Aid flow from UN agencies (US$) in Venezuela in 2006 to that in 2007?
Your response must be concise. 0.97. What is the ratio of the Aid flow from UN agencies (US$) in Latin America(all income levels) in 2006 to that in 2008?
Make the answer very short. 0.88. What is the ratio of the Aid flow from UN agencies (US$) of Sri Lanka in 2006 to that in 2008?
Offer a terse response. 2.4. What is the ratio of the Aid flow from UN agencies (US$) in Uzbekistan in 2006 to that in 2008?
Offer a terse response. 3.84. What is the ratio of the Aid flow from UN agencies (US$) of Venezuela in 2006 to that in 2008?
Your response must be concise. 2.4. What is the ratio of the Aid flow from UN agencies (US$) of Latin America(all income levels) in 2007 to that in 2008?
Keep it short and to the point. 0.96. What is the ratio of the Aid flow from UN agencies (US$) of Sri Lanka in 2007 to that in 2008?
Provide a short and direct response. 2.98. What is the ratio of the Aid flow from UN agencies (US$) of Uzbekistan in 2007 to that in 2008?
Provide a succinct answer. 3.14. What is the ratio of the Aid flow from UN agencies (US$) in Venezuela in 2007 to that in 2008?
Your answer should be very brief. 2.47. What is the difference between the highest and the second highest Aid flow from UN agencies (US$) of Latin America(all income levels)?
Provide a succinct answer. 7.87e+06. What is the difference between the highest and the second highest Aid flow from UN agencies (US$) in Venezuela?
Keep it short and to the point. 1.50e+05. What is the difference between the highest and the lowest Aid flow from UN agencies (US$) of Latin America(all income levels)?
Your answer should be very brief. 1.74e+07. What is the difference between the highest and the lowest Aid flow from UN agencies (US$) of Sri Lanka?
Your answer should be compact. 3.70e+06. What is the difference between the highest and the lowest Aid flow from UN agencies (US$) in Uzbekistan?
Provide a succinct answer. 1.05e+06. What is the difference between the highest and the lowest Aid flow from UN agencies (US$) in Venezuela?
Your answer should be compact. 1.37e+06. 